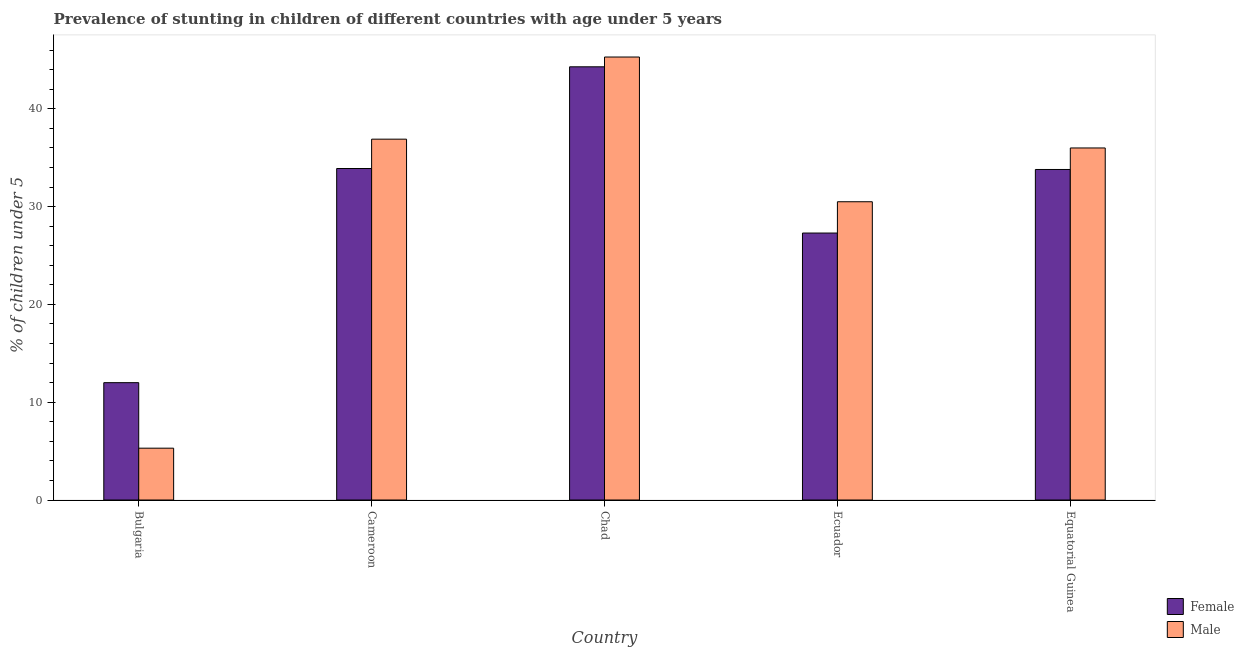What is the label of the 5th group of bars from the left?
Offer a terse response. Equatorial Guinea. In how many cases, is the number of bars for a given country not equal to the number of legend labels?
Ensure brevity in your answer.  0. What is the percentage of stunted female children in Ecuador?
Your answer should be compact. 27.3. Across all countries, what is the maximum percentage of stunted male children?
Give a very brief answer. 45.3. In which country was the percentage of stunted male children maximum?
Ensure brevity in your answer.  Chad. In which country was the percentage of stunted male children minimum?
Keep it short and to the point. Bulgaria. What is the total percentage of stunted male children in the graph?
Offer a terse response. 154. What is the difference between the percentage of stunted male children in Chad and that in Equatorial Guinea?
Ensure brevity in your answer.  9.3. What is the average percentage of stunted female children per country?
Make the answer very short. 30.26. What is the difference between the percentage of stunted female children and percentage of stunted male children in Bulgaria?
Keep it short and to the point. 6.7. In how many countries, is the percentage of stunted male children greater than 6 %?
Give a very brief answer. 4. What is the ratio of the percentage of stunted female children in Cameroon to that in Chad?
Give a very brief answer. 0.77. What is the difference between the highest and the second highest percentage of stunted male children?
Your answer should be very brief. 8.4. What is the difference between the highest and the lowest percentage of stunted male children?
Your answer should be very brief. 40. Is the sum of the percentage of stunted male children in Chad and Equatorial Guinea greater than the maximum percentage of stunted female children across all countries?
Keep it short and to the point. Yes. What does the 2nd bar from the left in Equatorial Guinea represents?
Offer a terse response. Male. How many countries are there in the graph?
Your response must be concise. 5. Are the values on the major ticks of Y-axis written in scientific E-notation?
Offer a terse response. No. Does the graph contain grids?
Your answer should be very brief. No. Where does the legend appear in the graph?
Make the answer very short. Bottom right. How are the legend labels stacked?
Ensure brevity in your answer.  Vertical. What is the title of the graph?
Offer a terse response. Prevalence of stunting in children of different countries with age under 5 years. Does "State government" appear as one of the legend labels in the graph?
Give a very brief answer. No. What is the label or title of the Y-axis?
Provide a succinct answer.  % of children under 5. What is the  % of children under 5 of Female in Bulgaria?
Give a very brief answer. 12. What is the  % of children under 5 of Male in Bulgaria?
Offer a very short reply. 5.3. What is the  % of children under 5 of Female in Cameroon?
Offer a very short reply. 33.9. What is the  % of children under 5 of Male in Cameroon?
Offer a very short reply. 36.9. What is the  % of children under 5 of Female in Chad?
Keep it short and to the point. 44.3. What is the  % of children under 5 of Male in Chad?
Your answer should be very brief. 45.3. What is the  % of children under 5 of Female in Ecuador?
Make the answer very short. 27.3. What is the  % of children under 5 of Male in Ecuador?
Your response must be concise. 30.5. What is the  % of children under 5 of Female in Equatorial Guinea?
Offer a terse response. 33.8. What is the  % of children under 5 in Male in Equatorial Guinea?
Your answer should be very brief. 36. Across all countries, what is the maximum  % of children under 5 in Female?
Make the answer very short. 44.3. Across all countries, what is the maximum  % of children under 5 in Male?
Ensure brevity in your answer.  45.3. Across all countries, what is the minimum  % of children under 5 in Male?
Offer a terse response. 5.3. What is the total  % of children under 5 in Female in the graph?
Your answer should be very brief. 151.3. What is the total  % of children under 5 in Male in the graph?
Make the answer very short. 154. What is the difference between the  % of children under 5 in Female in Bulgaria and that in Cameroon?
Give a very brief answer. -21.9. What is the difference between the  % of children under 5 of Male in Bulgaria and that in Cameroon?
Your answer should be compact. -31.6. What is the difference between the  % of children under 5 in Female in Bulgaria and that in Chad?
Your answer should be very brief. -32.3. What is the difference between the  % of children under 5 in Male in Bulgaria and that in Chad?
Offer a very short reply. -40. What is the difference between the  % of children under 5 of Female in Bulgaria and that in Ecuador?
Keep it short and to the point. -15.3. What is the difference between the  % of children under 5 of Male in Bulgaria and that in Ecuador?
Make the answer very short. -25.2. What is the difference between the  % of children under 5 in Female in Bulgaria and that in Equatorial Guinea?
Provide a succinct answer. -21.8. What is the difference between the  % of children under 5 in Male in Bulgaria and that in Equatorial Guinea?
Offer a terse response. -30.7. What is the difference between the  % of children under 5 in Female in Cameroon and that in Chad?
Offer a very short reply. -10.4. What is the difference between the  % of children under 5 of Male in Cameroon and that in Chad?
Keep it short and to the point. -8.4. What is the difference between the  % of children under 5 in Male in Cameroon and that in Ecuador?
Your response must be concise. 6.4. What is the difference between the  % of children under 5 of Male in Cameroon and that in Equatorial Guinea?
Make the answer very short. 0.9. What is the difference between the  % of children under 5 in Male in Chad and that in Ecuador?
Offer a terse response. 14.8. What is the difference between the  % of children under 5 in Female in Chad and that in Equatorial Guinea?
Offer a terse response. 10.5. What is the difference between the  % of children under 5 of Female in Bulgaria and the  % of children under 5 of Male in Cameroon?
Your answer should be compact. -24.9. What is the difference between the  % of children under 5 in Female in Bulgaria and the  % of children under 5 in Male in Chad?
Offer a very short reply. -33.3. What is the difference between the  % of children under 5 of Female in Bulgaria and the  % of children under 5 of Male in Ecuador?
Offer a terse response. -18.5. What is the difference between the  % of children under 5 in Female in Bulgaria and the  % of children under 5 in Male in Equatorial Guinea?
Keep it short and to the point. -24. What is the difference between the  % of children under 5 of Female in Cameroon and the  % of children under 5 of Male in Ecuador?
Your response must be concise. 3.4. What is the difference between the  % of children under 5 in Female in Cameroon and the  % of children under 5 in Male in Equatorial Guinea?
Make the answer very short. -2.1. What is the difference between the  % of children under 5 of Female in Chad and the  % of children under 5 of Male in Ecuador?
Keep it short and to the point. 13.8. What is the difference between the  % of children under 5 of Female in Chad and the  % of children under 5 of Male in Equatorial Guinea?
Provide a succinct answer. 8.3. What is the difference between the  % of children under 5 in Female in Ecuador and the  % of children under 5 in Male in Equatorial Guinea?
Make the answer very short. -8.7. What is the average  % of children under 5 in Female per country?
Provide a short and direct response. 30.26. What is the average  % of children under 5 of Male per country?
Provide a short and direct response. 30.8. What is the difference between the  % of children under 5 of Female and  % of children under 5 of Male in Bulgaria?
Your response must be concise. 6.7. What is the difference between the  % of children under 5 of Female and  % of children under 5 of Male in Cameroon?
Give a very brief answer. -3. What is the difference between the  % of children under 5 of Female and  % of children under 5 of Male in Chad?
Your answer should be very brief. -1. What is the ratio of the  % of children under 5 of Female in Bulgaria to that in Cameroon?
Your answer should be compact. 0.35. What is the ratio of the  % of children under 5 in Male in Bulgaria to that in Cameroon?
Offer a terse response. 0.14. What is the ratio of the  % of children under 5 in Female in Bulgaria to that in Chad?
Keep it short and to the point. 0.27. What is the ratio of the  % of children under 5 in Male in Bulgaria to that in Chad?
Ensure brevity in your answer.  0.12. What is the ratio of the  % of children under 5 of Female in Bulgaria to that in Ecuador?
Offer a very short reply. 0.44. What is the ratio of the  % of children under 5 in Male in Bulgaria to that in Ecuador?
Offer a terse response. 0.17. What is the ratio of the  % of children under 5 of Female in Bulgaria to that in Equatorial Guinea?
Provide a succinct answer. 0.35. What is the ratio of the  % of children under 5 of Male in Bulgaria to that in Equatorial Guinea?
Give a very brief answer. 0.15. What is the ratio of the  % of children under 5 in Female in Cameroon to that in Chad?
Ensure brevity in your answer.  0.77. What is the ratio of the  % of children under 5 of Male in Cameroon to that in Chad?
Give a very brief answer. 0.81. What is the ratio of the  % of children under 5 of Female in Cameroon to that in Ecuador?
Provide a short and direct response. 1.24. What is the ratio of the  % of children under 5 in Male in Cameroon to that in Ecuador?
Your answer should be compact. 1.21. What is the ratio of the  % of children under 5 of Female in Chad to that in Ecuador?
Ensure brevity in your answer.  1.62. What is the ratio of the  % of children under 5 of Male in Chad to that in Ecuador?
Your answer should be very brief. 1.49. What is the ratio of the  % of children under 5 in Female in Chad to that in Equatorial Guinea?
Offer a very short reply. 1.31. What is the ratio of the  % of children under 5 of Male in Chad to that in Equatorial Guinea?
Offer a terse response. 1.26. What is the ratio of the  % of children under 5 in Female in Ecuador to that in Equatorial Guinea?
Your response must be concise. 0.81. What is the ratio of the  % of children under 5 of Male in Ecuador to that in Equatorial Guinea?
Offer a very short reply. 0.85. What is the difference between the highest and the second highest  % of children under 5 in Female?
Make the answer very short. 10.4. What is the difference between the highest and the lowest  % of children under 5 in Female?
Ensure brevity in your answer.  32.3. 